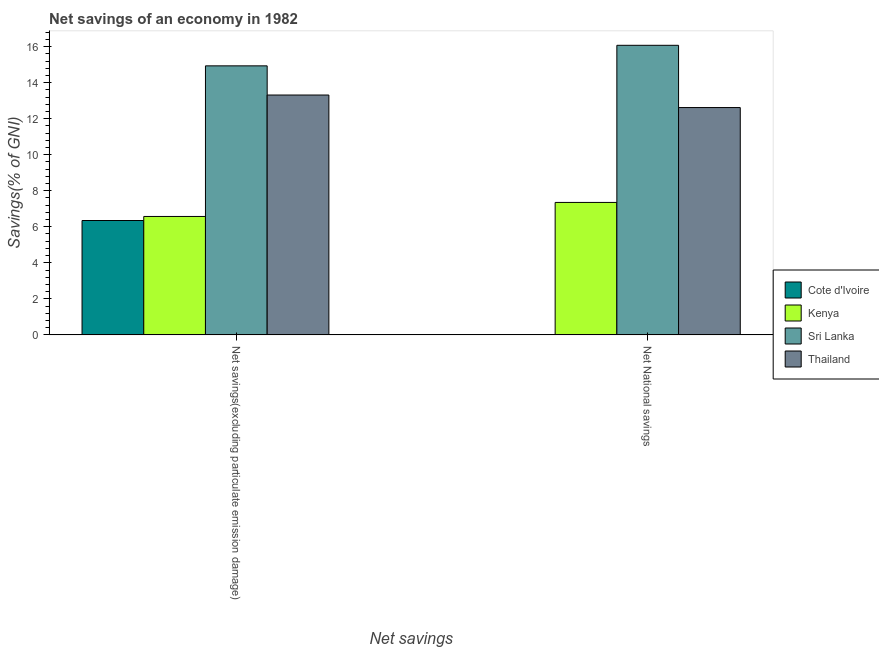How many different coloured bars are there?
Your answer should be compact. 4. Are the number of bars per tick equal to the number of legend labels?
Provide a short and direct response. No. How many bars are there on the 1st tick from the right?
Make the answer very short. 3. What is the label of the 1st group of bars from the left?
Ensure brevity in your answer.  Net savings(excluding particulate emission damage). What is the net national savings in Kenya?
Your response must be concise. 7.35. Across all countries, what is the maximum net savings(excluding particulate emission damage)?
Provide a succinct answer. 14.93. Across all countries, what is the minimum net savings(excluding particulate emission damage)?
Provide a short and direct response. 6.35. In which country was the net national savings maximum?
Give a very brief answer. Sri Lanka. What is the total net national savings in the graph?
Give a very brief answer. 36.04. What is the difference between the net savings(excluding particulate emission damage) in Sri Lanka and that in Kenya?
Provide a short and direct response. 8.36. What is the difference between the net savings(excluding particulate emission damage) in Sri Lanka and the net national savings in Kenya?
Offer a very short reply. 7.58. What is the average net national savings per country?
Offer a very short reply. 9.01. What is the difference between the net national savings and net savings(excluding particulate emission damage) in Kenya?
Offer a terse response. 0.78. In how many countries, is the net national savings greater than 5.2 %?
Give a very brief answer. 3. What is the ratio of the net savings(excluding particulate emission damage) in Cote d'Ivoire to that in Sri Lanka?
Offer a terse response. 0.43. Are the values on the major ticks of Y-axis written in scientific E-notation?
Your response must be concise. No. Does the graph contain any zero values?
Provide a succinct answer. Yes. How are the legend labels stacked?
Your answer should be very brief. Vertical. What is the title of the graph?
Your response must be concise. Net savings of an economy in 1982. What is the label or title of the X-axis?
Provide a short and direct response. Net savings. What is the label or title of the Y-axis?
Your response must be concise. Savings(% of GNI). What is the Savings(% of GNI) of Cote d'Ivoire in Net savings(excluding particulate emission damage)?
Make the answer very short. 6.35. What is the Savings(% of GNI) in Kenya in Net savings(excluding particulate emission damage)?
Your answer should be very brief. 6.57. What is the Savings(% of GNI) in Sri Lanka in Net savings(excluding particulate emission damage)?
Provide a succinct answer. 14.93. What is the Savings(% of GNI) of Thailand in Net savings(excluding particulate emission damage)?
Give a very brief answer. 13.31. What is the Savings(% of GNI) of Cote d'Ivoire in Net National savings?
Keep it short and to the point. 0. What is the Savings(% of GNI) in Kenya in Net National savings?
Keep it short and to the point. 7.35. What is the Savings(% of GNI) in Sri Lanka in Net National savings?
Provide a short and direct response. 16.07. What is the Savings(% of GNI) in Thailand in Net National savings?
Make the answer very short. 12.62. Across all Net savings, what is the maximum Savings(% of GNI) of Cote d'Ivoire?
Provide a succinct answer. 6.35. Across all Net savings, what is the maximum Savings(% of GNI) of Kenya?
Offer a very short reply. 7.35. Across all Net savings, what is the maximum Savings(% of GNI) in Sri Lanka?
Your answer should be compact. 16.07. Across all Net savings, what is the maximum Savings(% of GNI) in Thailand?
Offer a terse response. 13.31. Across all Net savings, what is the minimum Savings(% of GNI) of Cote d'Ivoire?
Give a very brief answer. 0. Across all Net savings, what is the minimum Savings(% of GNI) of Kenya?
Give a very brief answer. 6.57. Across all Net savings, what is the minimum Savings(% of GNI) of Sri Lanka?
Give a very brief answer. 14.93. Across all Net savings, what is the minimum Savings(% of GNI) of Thailand?
Your answer should be compact. 12.62. What is the total Savings(% of GNI) of Cote d'Ivoire in the graph?
Keep it short and to the point. 6.35. What is the total Savings(% of GNI) in Kenya in the graph?
Keep it short and to the point. 13.93. What is the total Savings(% of GNI) in Sri Lanka in the graph?
Keep it short and to the point. 31.01. What is the total Savings(% of GNI) in Thailand in the graph?
Offer a very short reply. 25.93. What is the difference between the Savings(% of GNI) of Kenya in Net savings(excluding particulate emission damage) and that in Net National savings?
Ensure brevity in your answer.  -0.78. What is the difference between the Savings(% of GNI) of Sri Lanka in Net savings(excluding particulate emission damage) and that in Net National savings?
Offer a very short reply. -1.14. What is the difference between the Savings(% of GNI) in Thailand in Net savings(excluding particulate emission damage) and that in Net National savings?
Your response must be concise. 0.7. What is the difference between the Savings(% of GNI) of Cote d'Ivoire in Net savings(excluding particulate emission damage) and the Savings(% of GNI) of Kenya in Net National savings?
Offer a terse response. -1. What is the difference between the Savings(% of GNI) in Cote d'Ivoire in Net savings(excluding particulate emission damage) and the Savings(% of GNI) in Sri Lanka in Net National savings?
Ensure brevity in your answer.  -9.72. What is the difference between the Savings(% of GNI) in Cote d'Ivoire in Net savings(excluding particulate emission damage) and the Savings(% of GNI) in Thailand in Net National savings?
Your answer should be very brief. -6.27. What is the difference between the Savings(% of GNI) of Kenya in Net savings(excluding particulate emission damage) and the Savings(% of GNI) of Sri Lanka in Net National savings?
Give a very brief answer. -9.5. What is the difference between the Savings(% of GNI) of Kenya in Net savings(excluding particulate emission damage) and the Savings(% of GNI) of Thailand in Net National savings?
Your answer should be compact. -6.04. What is the difference between the Savings(% of GNI) in Sri Lanka in Net savings(excluding particulate emission damage) and the Savings(% of GNI) in Thailand in Net National savings?
Make the answer very short. 2.31. What is the average Savings(% of GNI) of Cote d'Ivoire per Net savings?
Your answer should be compact. 3.17. What is the average Savings(% of GNI) in Kenya per Net savings?
Your response must be concise. 6.96. What is the average Savings(% of GNI) of Sri Lanka per Net savings?
Offer a very short reply. 15.5. What is the average Savings(% of GNI) of Thailand per Net savings?
Keep it short and to the point. 12.97. What is the difference between the Savings(% of GNI) in Cote d'Ivoire and Savings(% of GNI) in Kenya in Net savings(excluding particulate emission damage)?
Provide a succinct answer. -0.22. What is the difference between the Savings(% of GNI) in Cote d'Ivoire and Savings(% of GNI) in Sri Lanka in Net savings(excluding particulate emission damage)?
Your response must be concise. -8.58. What is the difference between the Savings(% of GNI) in Cote d'Ivoire and Savings(% of GNI) in Thailand in Net savings(excluding particulate emission damage)?
Your answer should be compact. -6.97. What is the difference between the Savings(% of GNI) of Kenya and Savings(% of GNI) of Sri Lanka in Net savings(excluding particulate emission damage)?
Your response must be concise. -8.36. What is the difference between the Savings(% of GNI) in Kenya and Savings(% of GNI) in Thailand in Net savings(excluding particulate emission damage)?
Offer a terse response. -6.74. What is the difference between the Savings(% of GNI) in Sri Lanka and Savings(% of GNI) in Thailand in Net savings(excluding particulate emission damage)?
Your answer should be very brief. 1.62. What is the difference between the Savings(% of GNI) in Kenya and Savings(% of GNI) in Sri Lanka in Net National savings?
Give a very brief answer. -8.72. What is the difference between the Savings(% of GNI) in Kenya and Savings(% of GNI) in Thailand in Net National savings?
Your answer should be very brief. -5.27. What is the difference between the Savings(% of GNI) of Sri Lanka and Savings(% of GNI) of Thailand in Net National savings?
Provide a succinct answer. 3.46. What is the ratio of the Savings(% of GNI) in Kenya in Net savings(excluding particulate emission damage) to that in Net National savings?
Provide a short and direct response. 0.89. What is the ratio of the Savings(% of GNI) of Sri Lanka in Net savings(excluding particulate emission damage) to that in Net National savings?
Your response must be concise. 0.93. What is the ratio of the Savings(% of GNI) in Thailand in Net savings(excluding particulate emission damage) to that in Net National savings?
Your answer should be compact. 1.06. What is the difference between the highest and the second highest Savings(% of GNI) of Kenya?
Give a very brief answer. 0.78. What is the difference between the highest and the second highest Savings(% of GNI) of Sri Lanka?
Your answer should be compact. 1.14. What is the difference between the highest and the second highest Savings(% of GNI) of Thailand?
Your answer should be compact. 0.7. What is the difference between the highest and the lowest Savings(% of GNI) in Cote d'Ivoire?
Ensure brevity in your answer.  6.35. What is the difference between the highest and the lowest Savings(% of GNI) in Kenya?
Your response must be concise. 0.78. What is the difference between the highest and the lowest Savings(% of GNI) in Sri Lanka?
Make the answer very short. 1.14. What is the difference between the highest and the lowest Savings(% of GNI) of Thailand?
Provide a succinct answer. 0.7. 